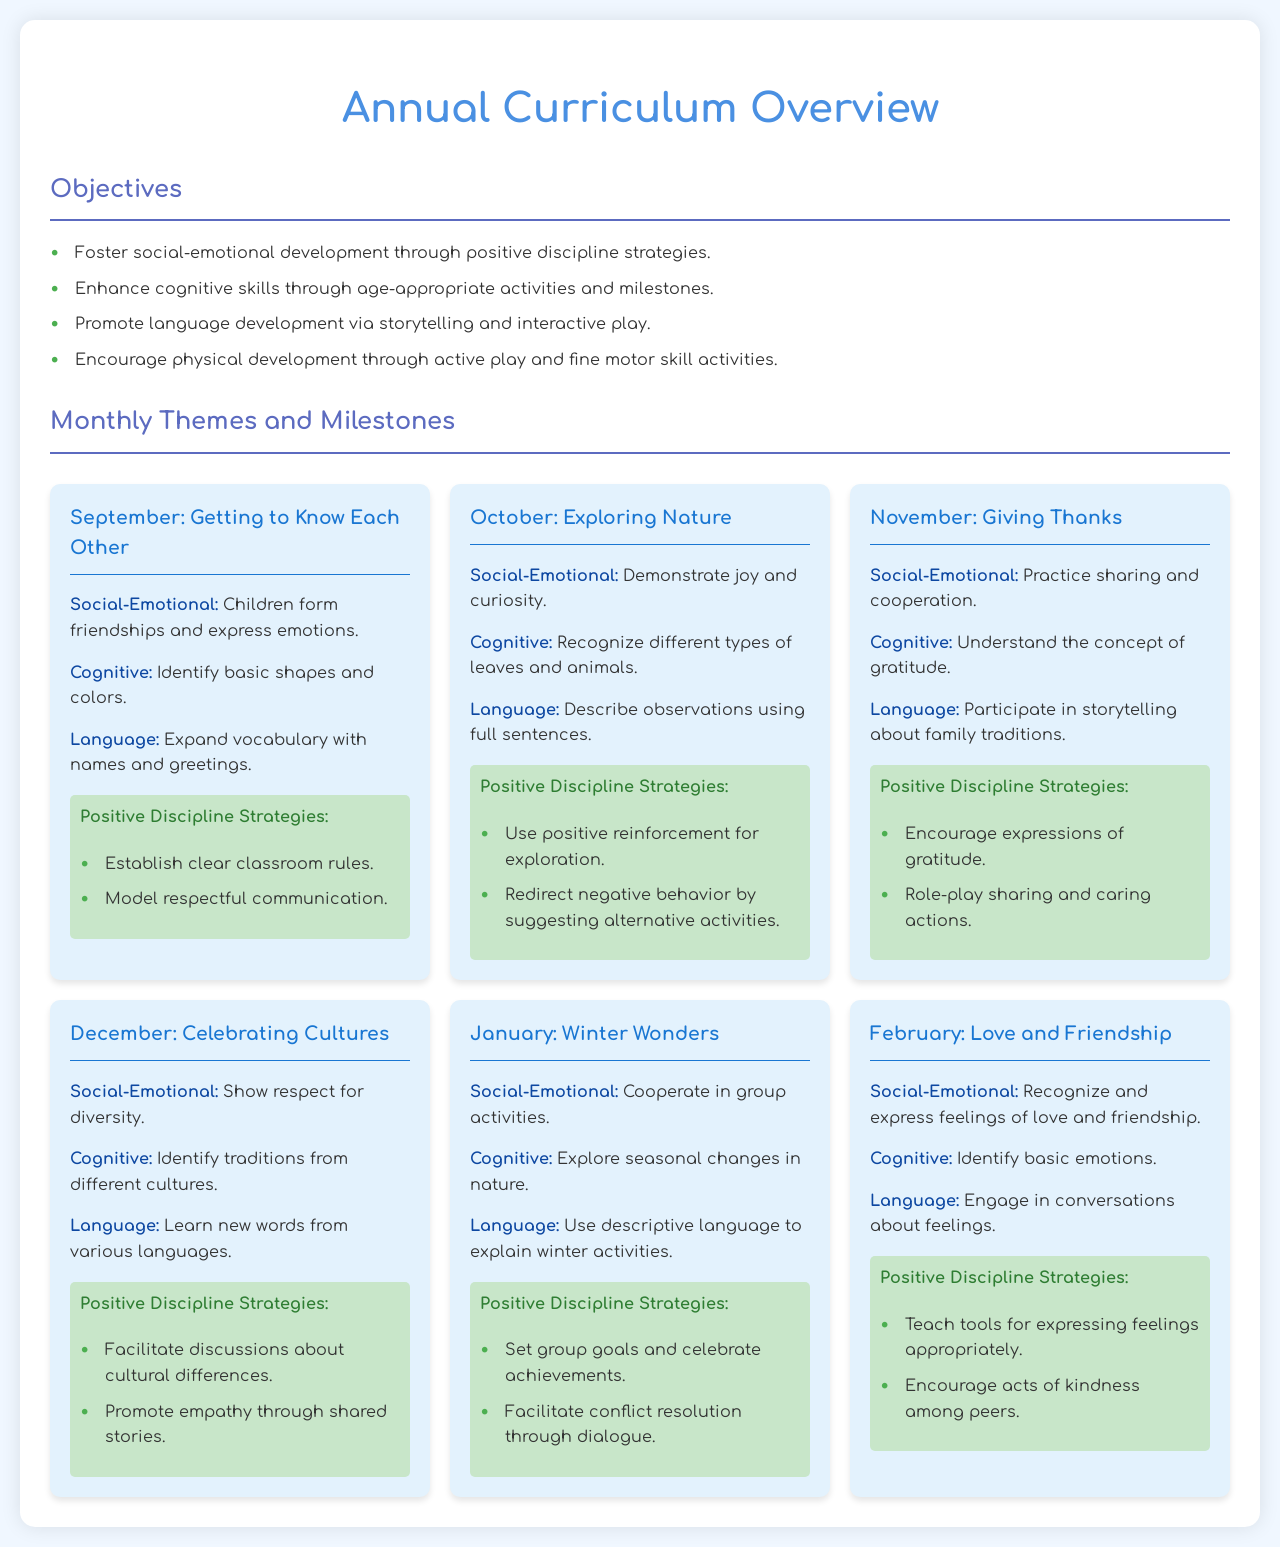What is the theme for November? The theme for November is "Giving Thanks," which is mentioned in the document.
Answer: Giving Thanks What aspect of development is emphasized in January? The January milestones focus on social-emotional development, as indicated in the document.
Answer: Social-Emotional How many positive discipline strategies are listed for February? There are two positive discipline strategies listed for February in the document.
Answer: 2 What is one cognitive milestone for September? The cognitive milestone for September includes identifying basic shapes and colors, which is specified in the document.
Answer: Identify basic shapes and colors What is a positive discipline strategy for October? The document lists "Use positive reinforcement for exploration" as a positive discipline strategy for October.
Answer: Use positive reinforcement for exploration Which month focuses on cultural diversity? The month that focuses on cultural diversity is December, as outlined in the document.
Answer: December What emotion is recognized in February's milestones? In February, children recognize and express feelings of love and friendship, as stated in the document.
Answer: Love and friendship What activity promotes language development according to the objectives? Storytelling is highlighted as an activity that promotes language development in the objectives section of the document.
Answer: Storytelling What is one social-emotional milestone for June? The document does not mention June, so there is no information on milestones for that month.
Answer: N/A 